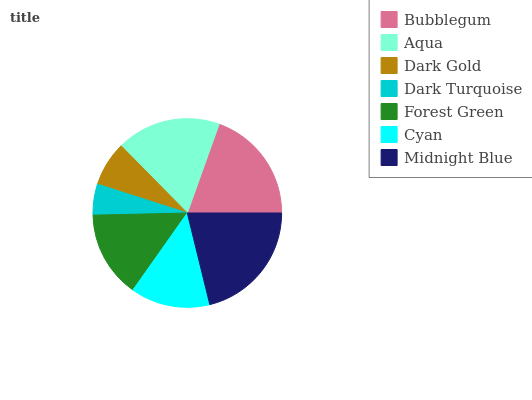Is Dark Turquoise the minimum?
Answer yes or no. Yes. Is Midnight Blue the maximum?
Answer yes or no. Yes. Is Aqua the minimum?
Answer yes or no. No. Is Aqua the maximum?
Answer yes or no. No. Is Bubblegum greater than Aqua?
Answer yes or no. Yes. Is Aqua less than Bubblegum?
Answer yes or no. Yes. Is Aqua greater than Bubblegum?
Answer yes or no. No. Is Bubblegum less than Aqua?
Answer yes or no. No. Is Forest Green the high median?
Answer yes or no. Yes. Is Forest Green the low median?
Answer yes or no. Yes. Is Dark Turquoise the high median?
Answer yes or no. No. Is Cyan the low median?
Answer yes or no. No. 